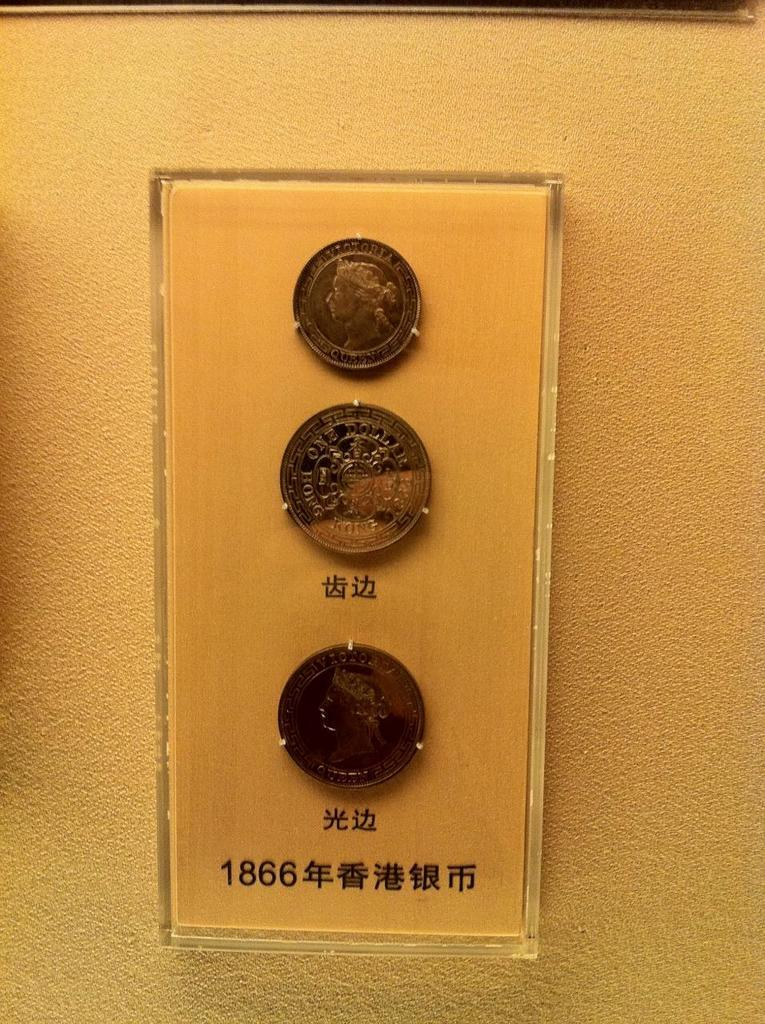<image>
Render a clear and concise summary of the photo. Three old coins on display on a wall made out of a material that looks like copper, in the wall words in a foreign language and the year 1866. 